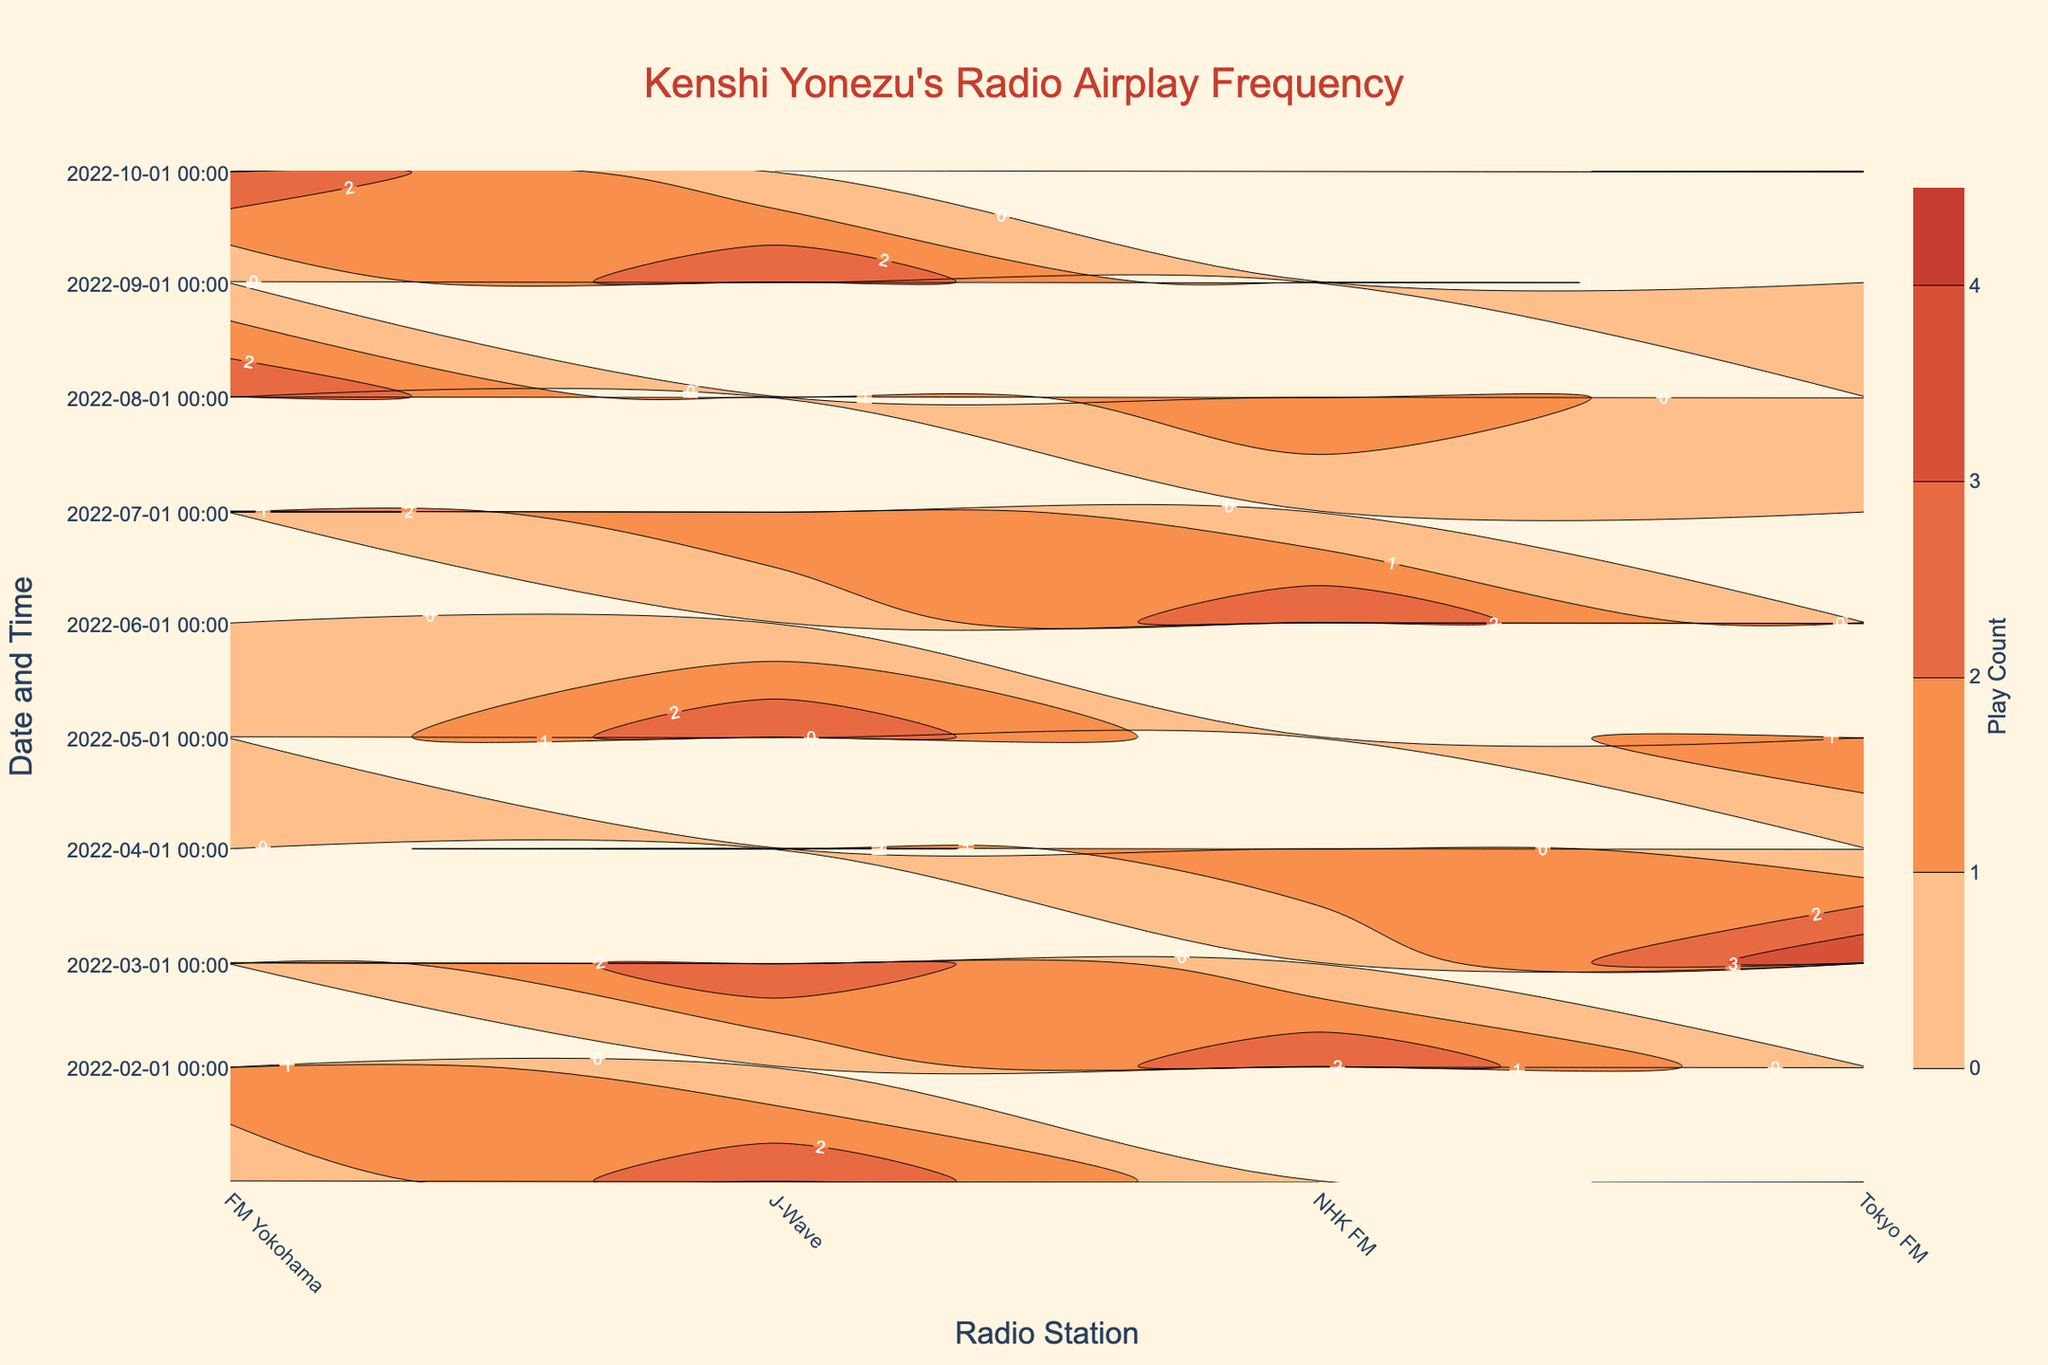What is the title of the contour plot? Look at the top centre of the figure where the title is usually placed. The displayed text is the title.
Answer: Kenshi Yonezu's Radio Airplay Frequency What do the colors on the contour plot represent? Refer to the color bar legend on the right-hand side of the figure to determine what the different colors signify.
Answer: Play Count Which radio station has the highest play count and when did it occur? Identify the point with the darkest or most saturated color on the contour plot. Check the y-axis for the corresponding DateTime and the x-axis for the Radio Station.
Answer: Tokyo FM, 2022-03-01 18:00 How does the play count for J-Wave on 2022-07-01 compare to the play count for NHK FM on 2022-08-01? Find the y-coordinate for both dates. Look at the x-axis to locate J-Wave for 2022-07-01 and NHK FM for 2022-08-01. Compare the colors of both points.
Answer: J-Wave has a higher play count on 2022-07-01 What is the general trend in the average song duration for Kenshi Yonezu's songs over the entire period? Although this isn't directly in the contour plot, general observation of playcounts and the station tendencies for song durations can give insights.
Answer: No clear trend in the data shown On which date did FM Yokohama have the least number of plays, and how many plays did it have? Look for FM Yokohama data on x-axis and locate the position with the lightest color. Refer to the y-axis for the date and the color legend for the play count.
Answer: 2022-06-01, 1 play Which time period shows the most plays for NHK FM? Locate the places with the darkest color associated with NHK FM on x-axis and cross-reference to the times/dates on y-axis.
Answer: August 1, 2022, 18:00 If you sum the play counts of Tokyo FM on all dates at 18:00, what is the total? Find all the points corresponding to Tokyo FM on the x-axis and y-axis at 18:00. Sum the respective play counts from the color intensities.
Answer: 12 Between FM Yokohama and J-Wave, which station had the more consistent play count across the given timeframe? Assess the smoothness and uniformity of the colors along the lines for each station on the x-axis.
Answer: J-Wave What can you infer about the popularity of Kenshi Yonezu's songs on Tokyo FM compared to NHK FM? Look at the overall intensities of their respective colors on the contour. Compare the number of higher intensity areas.
Answer: More popular on Tokyo FM 